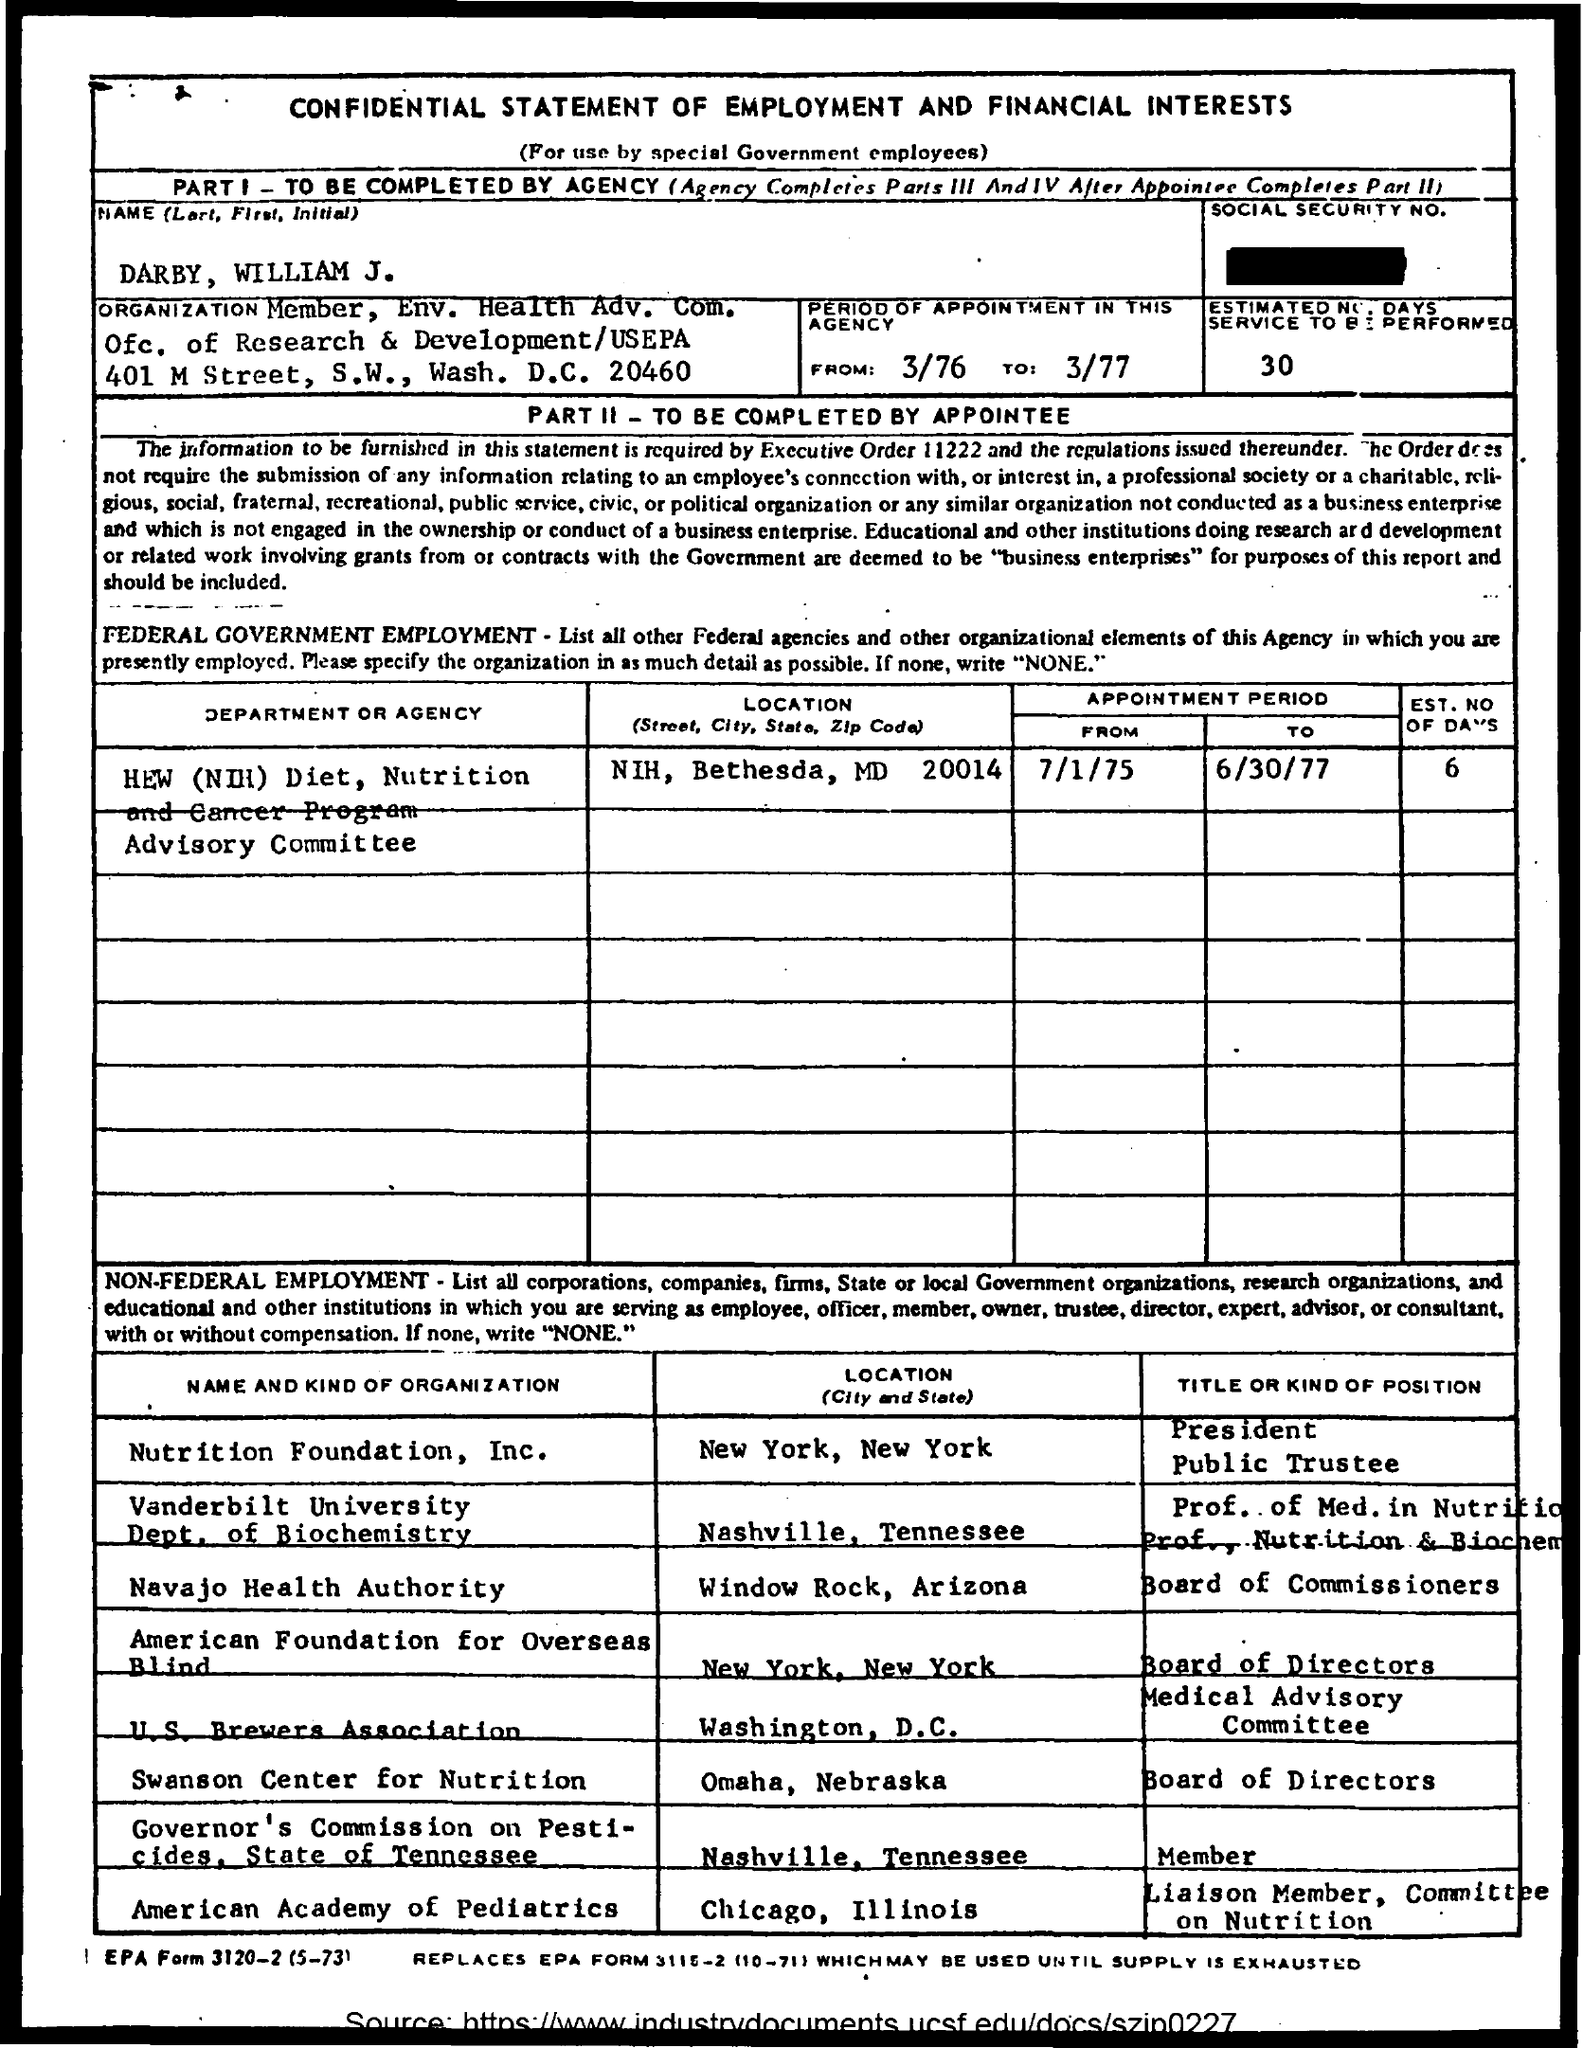What is title of the document?
Offer a very short reply. Confidential Statement of Employment and Financial Interests. Who should complete part i of the form?
Make the answer very short. To be completed by agency. What is the location of nutrition foundation, inc ?
Make the answer very short. New York, New York. What is the location of vanderbilt university dept. of biochemistry?
Your answer should be very brief. Nashville, Tennessee. What is the location of navajo health authority ?
Your response must be concise. Window Rock, Arizona. What is the location of american academy of pediatrics?
Your answer should be compact. Chicago, Illinois. What is the location of swanson center for nutrition ?
Give a very brief answer. Omaha, Nebraska. What is the location of  u.s.  brewers association ?
Offer a very short reply. Washington , D.C. 